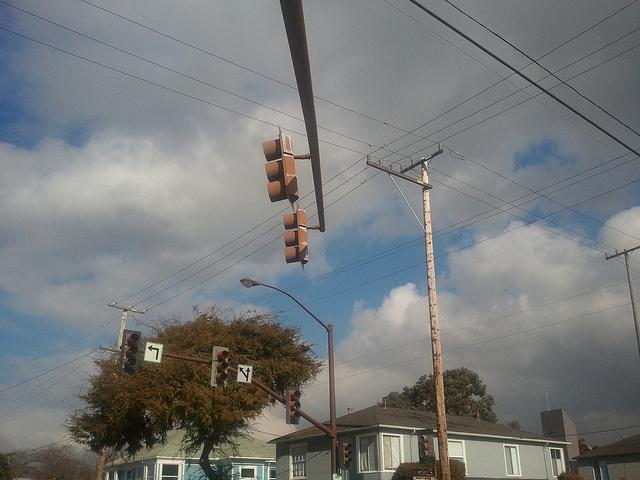Is there a streetlight in the photo?
Quick response, please. Yes. Is the street light red?
Keep it brief. Yes. How many cars are visible on this street?
Give a very brief answer. 0. What are the objects toward the top of the pole on the far right?
Answer briefly. Power lines. What is the weather?
Keep it brief. Cloudy. What is missing on the tree?
Answer briefly. Nothing. Are there any clouds in the sky?
Quick response, please. Yes. What is behind the light?
Write a very short answer. Pole. What kind of clouds are these?
Short answer required. Cumulus. What color is the top of the house on the right?
Keep it brief. Gray. Is the sky clear?
Keep it brief. No. 